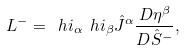<formula> <loc_0><loc_0><loc_500><loc_500>L ^ { - } = \ h { i } _ { \alpha } \ h { i } _ { \beta } \hat { J } ^ { \alpha } { \frac { { D } { \eta } ^ { \beta } } { { D } \hat { S } ^ { - } } } ,</formula> 